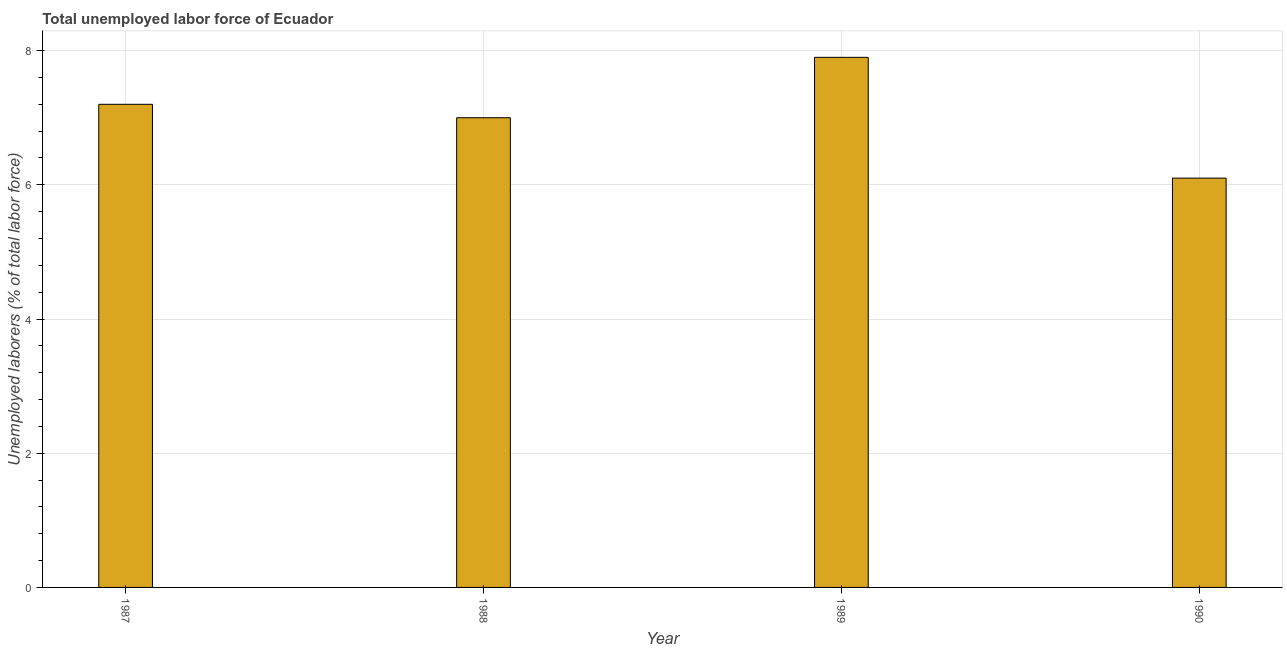Does the graph contain any zero values?
Your answer should be compact. No. Does the graph contain grids?
Provide a short and direct response. Yes. What is the title of the graph?
Your answer should be compact. Total unemployed labor force of Ecuador. What is the label or title of the Y-axis?
Your answer should be compact. Unemployed laborers (% of total labor force). What is the total unemployed labour force in 1990?
Offer a very short reply. 6.1. Across all years, what is the maximum total unemployed labour force?
Your response must be concise. 7.9. Across all years, what is the minimum total unemployed labour force?
Your answer should be compact. 6.1. In which year was the total unemployed labour force maximum?
Give a very brief answer. 1989. In which year was the total unemployed labour force minimum?
Provide a short and direct response. 1990. What is the sum of the total unemployed labour force?
Make the answer very short. 28.2. What is the difference between the total unemployed labour force in 1987 and 1988?
Keep it short and to the point. 0.2. What is the average total unemployed labour force per year?
Provide a short and direct response. 7.05. What is the median total unemployed labour force?
Make the answer very short. 7.1. In how many years, is the total unemployed labour force greater than 0.4 %?
Give a very brief answer. 4. What is the ratio of the total unemployed labour force in 1987 to that in 1988?
Your response must be concise. 1.03. Is the total unemployed labour force in 1987 less than that in 1989?
Make the answer very short. Yes. Is the difference between the total unemployed labour force in 1987 and 1988 greater than the difference between any two years?
Offer a very short reply. No. How many years are there in the graph?
Your response must be concise. 4. What is the difference between two consecutive major ticks on the Y-axis?
Ensure brevity in your answer.  2. Are the values on the major ticks of Y-axis written in scientific E-notation?
Ensure brevity in your answer.  No. What is the Unemployed laborers (% of total labor force) of 1987?
Provide a short and direct response. 7.2. What is the Unemployed laborers (% of total labor force) of 1989?
Your answer should be compact. 7.9. What is the Unemployed laborers (% of total labor force) of 1990?
Your answer should be compact. 6.1. What is the difference between the Unemployed laborers (% of total labor force) in 1987 and 1989?
Your answer should be compact. -0.7. What is the difference between the Unemployed laborers (% of total labor force) in 1987 and 1990?
Make the answer very short. 1.1. What is the difference between the Unemployed laborers (% of total labor force) in 1988 and 1989?
Make the answer very short. -0.9. What is the difference between the Unemployed laborers (% of total labor force) in 1988 and 1990?
Ensure brevity in your answer.  0.9. What is the ratio of the Unemployed laborers (% of total labor force) in 1987 to that in 1988?
Make the answer very short. 1.03. What is the ratio of the Unemployed laborers (% of total labor force) in 1987 to that in 1989?
Your answer should be very brief. 0.91. What is the ratio of the Unemployed laborers (% of total labor force) in 1987 to that in 1990?
Offer a very short reply. 1.18. What is the ratio of the Unemployed laborers (% of total labor force) in 1988 to that in 1989?
Provide a short and direct response. 0.89. What is the ratio of the Unemployed laborers (% of total labor force) in 1988 to that in 1990?
Offer a very short reply. 1.15. What is the ratio of the Unemployed laborers (% of total labor force) in 1989 to that in 1990?
Your response must be concise. 1.29. 